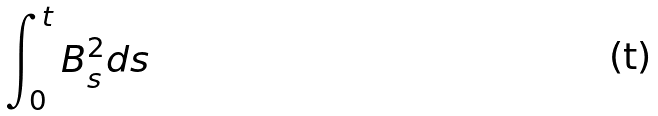<formula> <loc_0><loc_0><loc_500><loc_500>\int _ { 0 } ^ { t } B _ { s } ^ { 2 } d s</formula> 